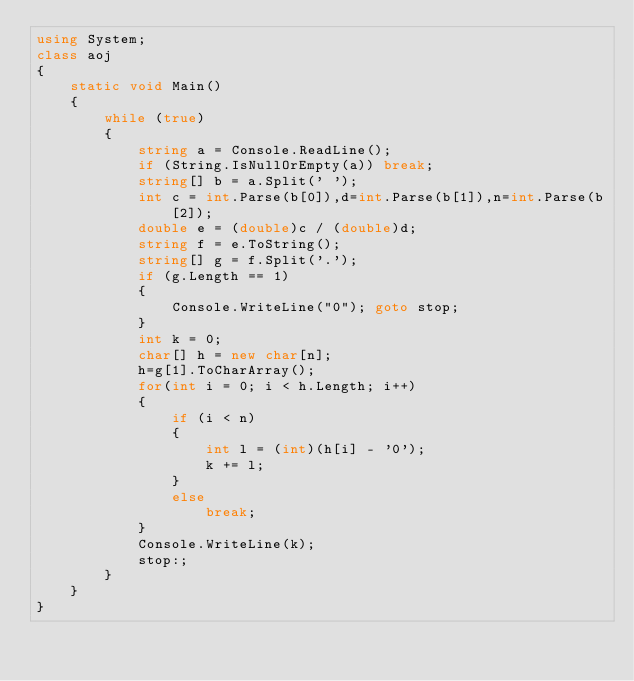Convert code to text. <code><loc_0><loc_0><loc_500><loc_500><_C#_>using System;
class aoj
{
    static void Main()
    {
        while (true)
        {
            string a = Console.ReadLine();
            if (String.IsNullOrEmpty(a)) break;
            string[] b = a.Split(' ');
            int c = int.Parse(b[0]),d=int.Parse(b[1]),n=int.Parse(b[2]);
            double e = (double)c / (double)d;
            string f = e.ToString();
            string[] g = f.Split('.');
            if (g.Length == 1)
            {
                Console.WriteLine("0"); goto stop;
            }
            int k = 0;
            char[] h = new char[n];
            h=g[1].ToCharArray();
            for(int i = 0; i < h.Length; i++)
            {
                if (i < n)
                {
                    int l = (int)(h[i] - '0');
                    k += l;
                }
                else
                    break;
            }
            Console.WriteLine(k);
            stop:;
        }
    }
}</code> 